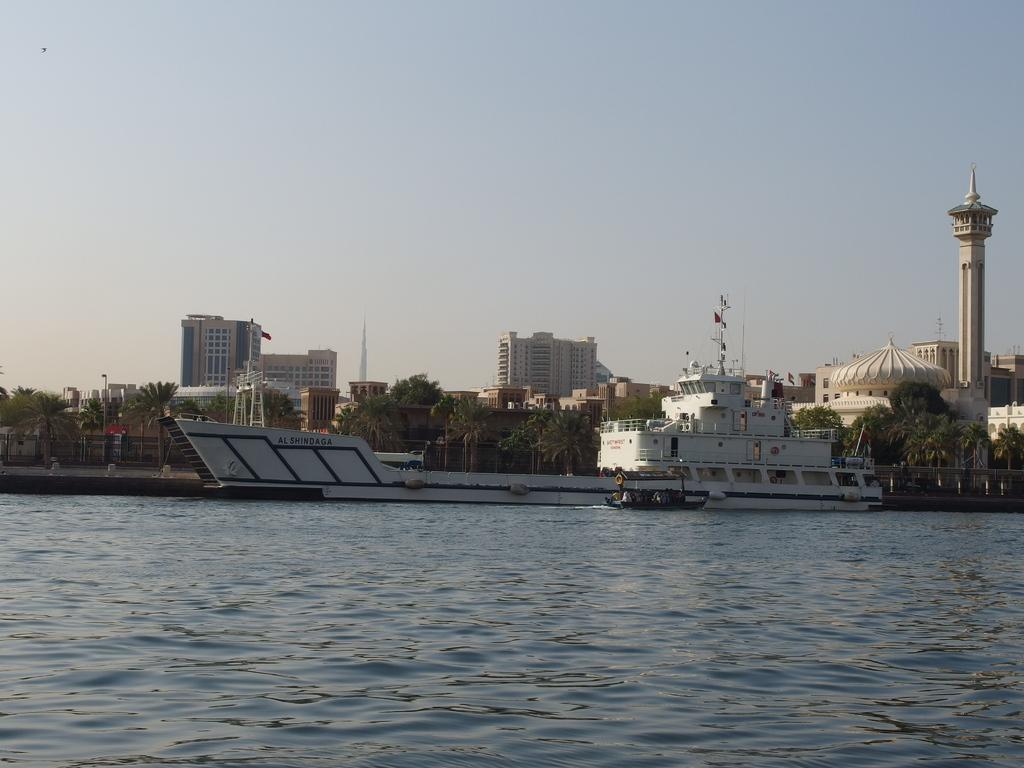What type of vehicle is in the water in the image? There is a white navy ship in the water in the image. What type of trees can be seen in the image? There are coconut trees visible in the image. What type of structure is present in the image? There is a building in the image. What type of religious building can be seen on the right side of the image? There is a brown-colored mosque on the right side of the image. How many yaks are visible in the image? There are no yaks present in the image. What type of door is featured on the mosque in the image? The image does not show the door of the mosque, so it cannot be determined from the image. 